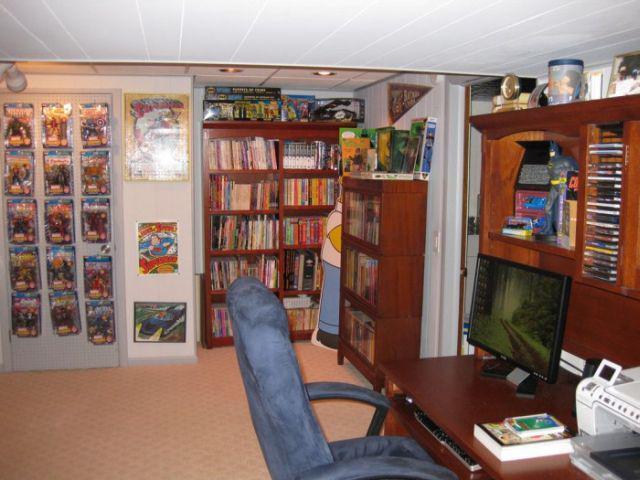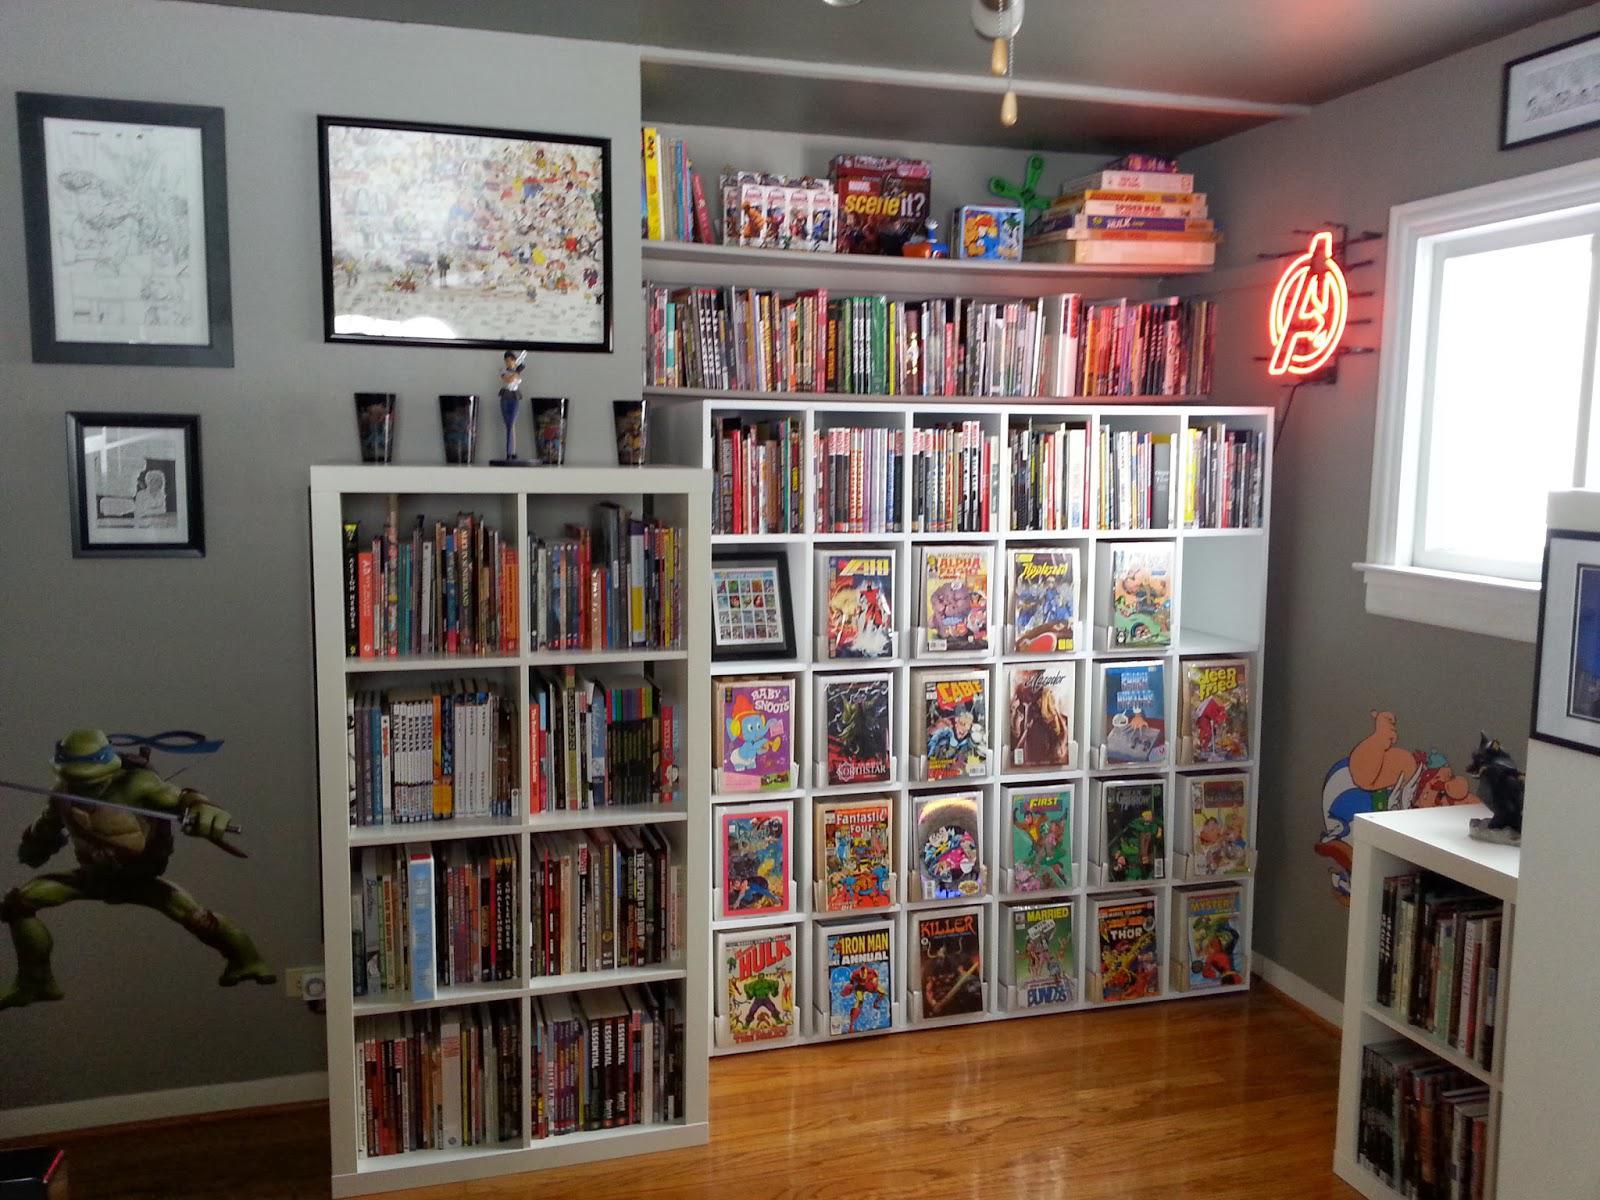The first image is the image on the left, the second image is the image on the right. Given the left and right images, does the statement "There are no fewer than four framed images in the image on the right." hold true? Answer yes or no. Yes. 